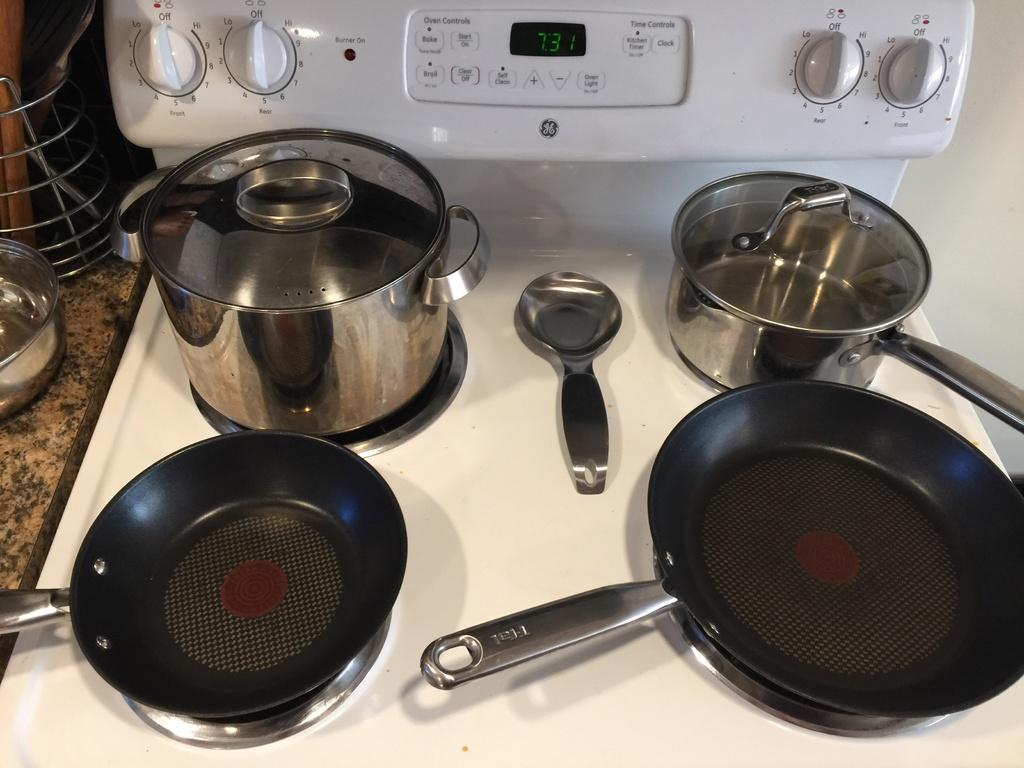<image>
Summarize the visual content of the image. pots and pans on a GE stove top with digital clock at 7:31 